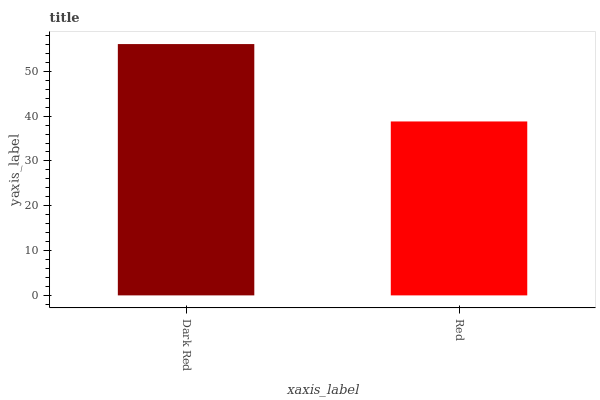Is Red the minimum?
Answer yes or no. Yes. Is Dark Red the maximum?
Answer yes or no. Yes. Is Red the maximum?
Answer yes or no. No. Is Dark Red greater than Red?
Answer yes or no. Yes. Is Red less than Dark Red?
Answer yes or no. Yes. Is Red greater than Dark Red?
Answer yes or no. No. Is Dark Red less than Red?
Answer yes or no. No. Is Dark Red the high median?
Answer yes or no. Yes. Is Red the low median?
Answer yes or no. Yes. Is Red the high median?
Answer yes or no. No. Is Dark Red the low median?
Answer yes or no. No. 